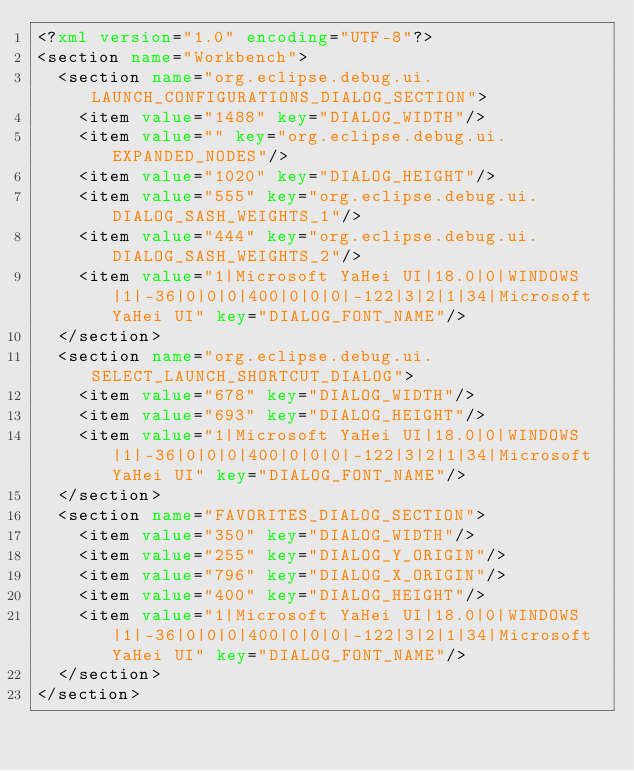Convert code to text. <code><loc_0><loc_0><loc_500><loc_500><_XML_><?xml version="1.0" encoding="UTF-8"?>
<section name="Workbench">
	<section name="org.eclipse.debug.ui.LAUNCH_CONFIGURATIONS_DIALOG_SECTION">
		<item value="1488" key="DIALOG_WIDTH"/>
		<item value="" key="org.eclipse.debug.ui.EXPANDED_NODES"/>
		<item value="1020" key="DIALOG_HEIGHT"/>
		<item value="555" key="org.eclipse.debug.ui.DIALOG_SASH_WEIGHTS_1"/>
		<item value="444" key="org.eclipse.debug.ui.DIALOG_SASH_WEIGHTS_2"/>
		<item value="1|Microsoft YaHei UI|18.0|0|WINDOWS|1|-36|0|0|0|400|0|0|0|-122|3|2|1|34|Microsoft YaHei UI" key="DIALOG_FONT_NAME"/>
	</section>
	<section name="org.eclipse.debug.ui.SELECT_LAUNCH_SHORTCUT_DIALOG">
		<item value="678" key="DIALOG_WIDTH"/>
		<item value="693" key="DIALOG_HEIGHT"/>
		<item value="1|Microsoft YaHei UI|18.0|0|WINDOWS|1|-36|0|0|0|400|0|0|0|-122|3|2|1|34|Microsoft YaHei UI" key="DIALOG_FONT_NAME"/>
	</section>
	<section name="FAVORITES_DIALOG_SECTION">
		<item value="350" key="DIALOG_WIDTH"/>
		<item value="255" key="DIALOG_Y_ORIGIN"/>
		<item value="796" key="DIALOG_X_ORIGIN"/>
		<item value="400" key="DIALOG_HEIGHT"/>
		<item value="1|Microsoft YaHei UI|18.0|0|WINDOWS|1|-36|0|0|0|400|0|0|0|-122|3|2|1|34|Microsoft YaHei UI" key="DIALOG_FONT_NAME"/>
	</section>
</section>
</code> 